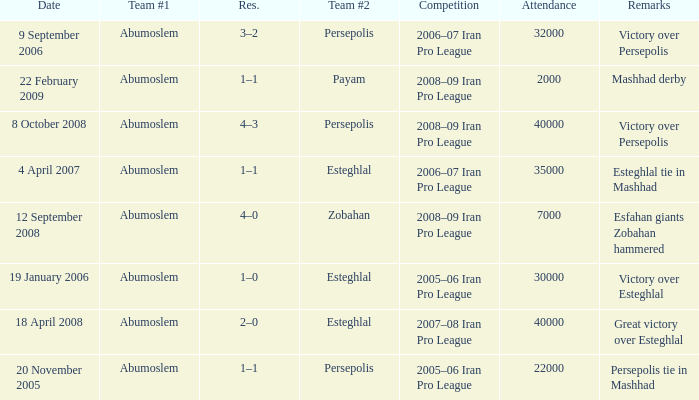What were the comments made on october 8, 2008? Victory over Persepolis. 